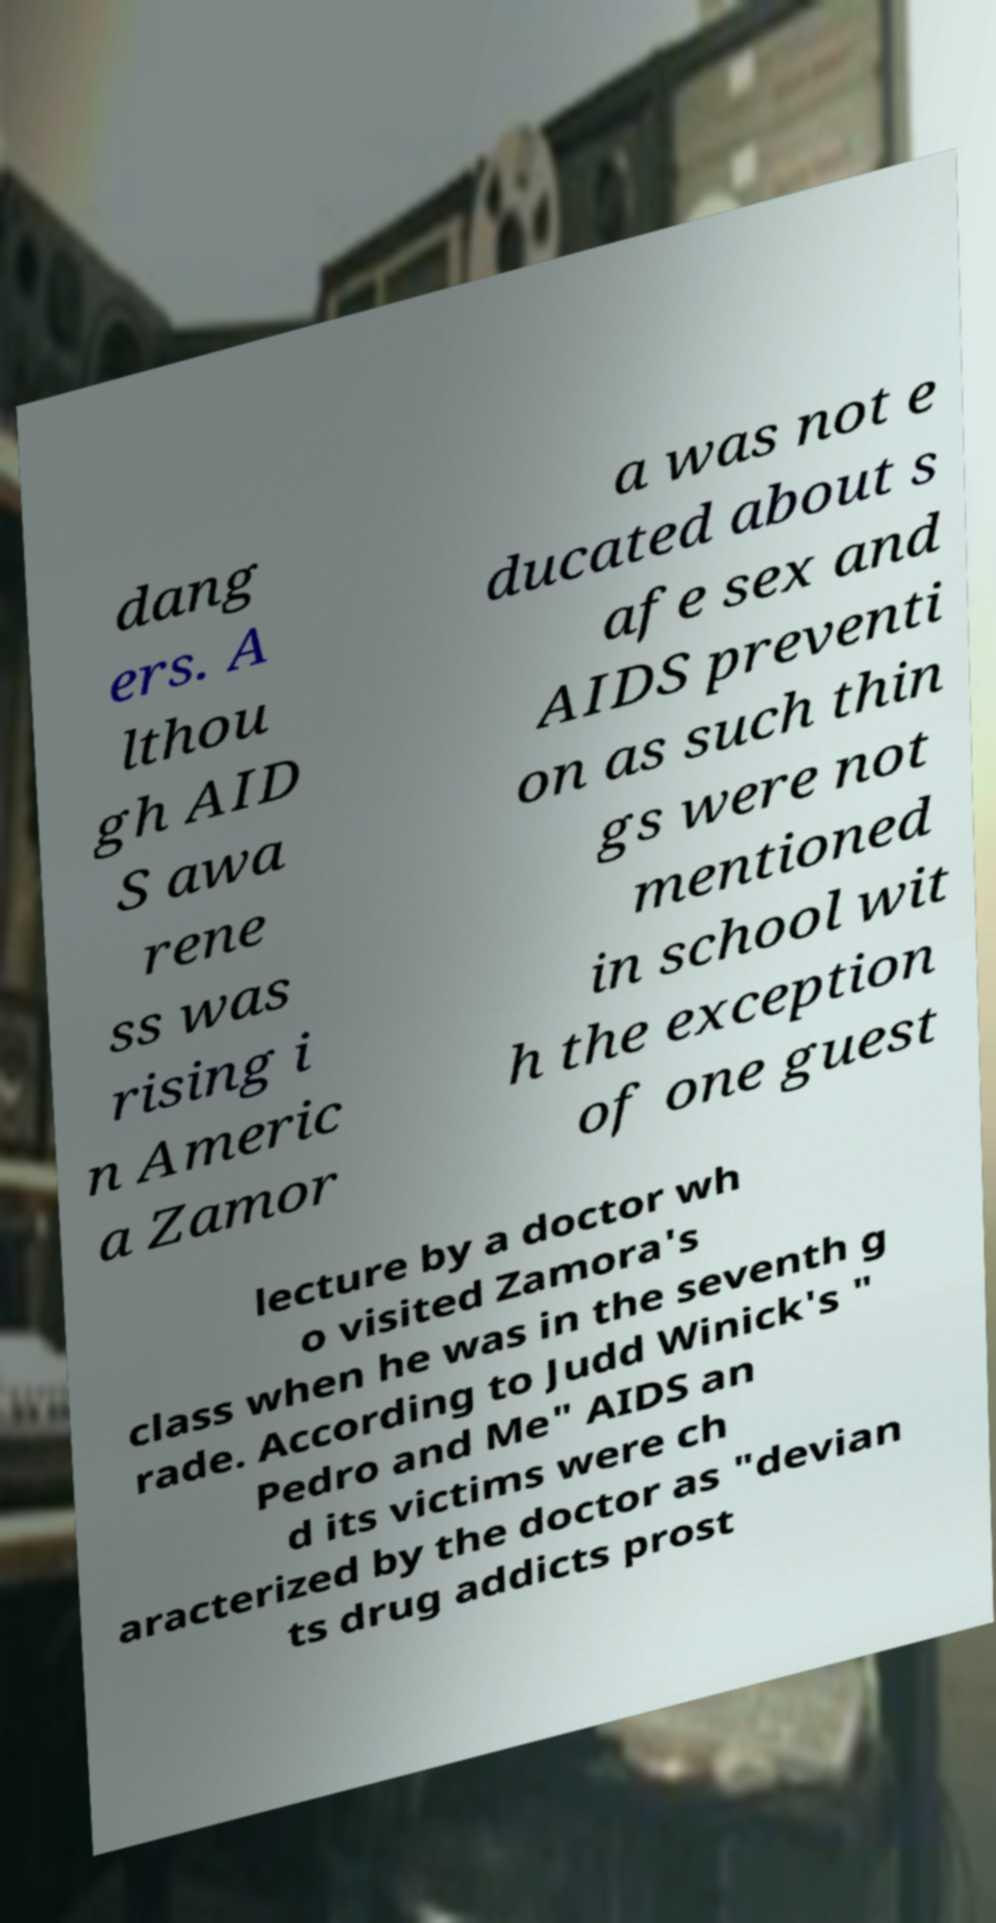Please identify and transcribe the text found in this image. dang ers. A lthou gh AID S awa rene ss was rising i n Americ a Zamor a was not e ducated about s afe sex and AIDS preventi on as such thin gs were not mentioned in school wit h the exception of one guest lecture by a doctor wh o visited Zamora's class when he was in the seventh g rade. According to Judd Winick's " Pedro and Me" AIDS an d its victims were ch aracterized by the doctor as "devian ts drug addicts prost 